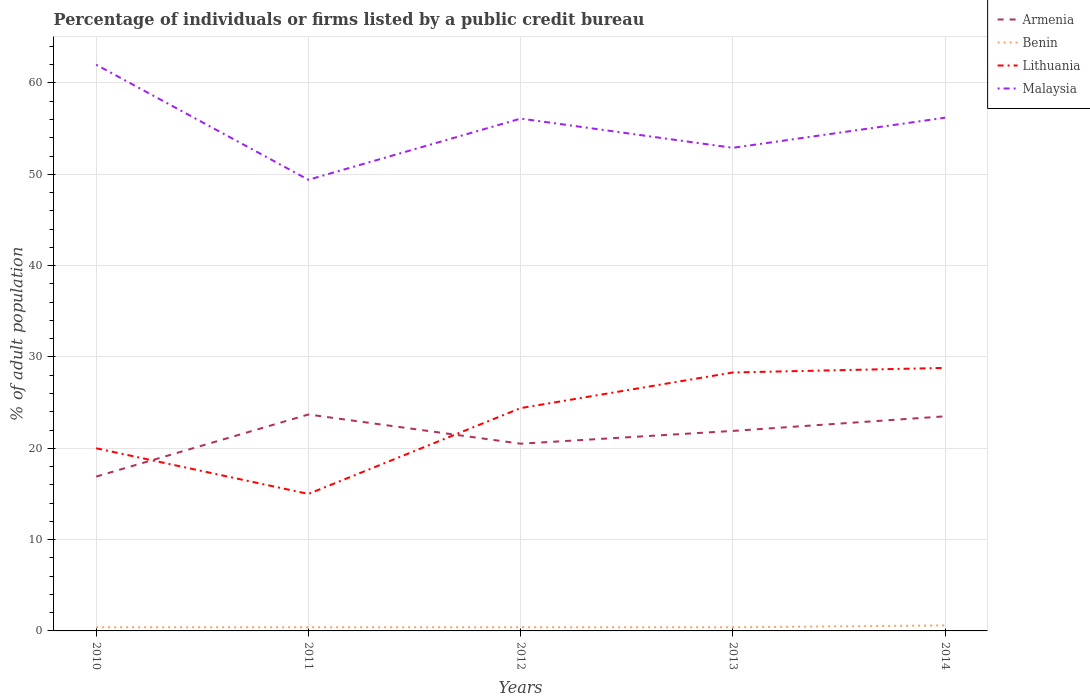How many different coloured lines are there?
Offer a very short reply. 4. Is the number of lines equal to the number of legend labels?
Provide a short and direct response. Yes. What is the total percentage of population listed by a public credit bureau in Malaysia in the graph?
Offer a terse response. 5.8. What is the difference between the highest and the second highest percentage of population listed by a public credit bureau in Malaysia?
Offer a very short reply. 12.6. What is the difference between the highest and the lowest percentage of population listed by a public credit bureau in Lithuania?
Your answer should be compact. 3. How many years are there in the graph?
Keep it short and to the point. 5. What is the difference between two consecutive major ticks on the Y-axis?
Offer a terse response. 10. Where does the legend appear in the graph?
Make the answer very short. Top right. What is the title of the graph?
Provide a short and direct response. Percentage of individuals or firms listed by a public credit bureau. Does "Bangladesh" appear as one of the legend labels in the graph?
Ensure brevity in your answer.  No. What is the label or title of the Y-axis?
Keep it short and to the point. % of adult population. What is the % of adult population of Armenia in 2011?
Make the answer very short. 23.7. What is the % of adult population in Benin in 2011?
Make the answer very short. 0.4. What is the % of adult population of Malaysia in 2011?
Keep it short and to the point. 49.4. What is the % of adult population of Lithuania in 2012?
Keep it short and to the point. 24.4. What is the % of adult population in Malaysia in 2012?
Make the answer very short. 56.1. What is the % of adult population of Armenia in 2013?
Keep it short and to the point. 21.9. What is the % of adult population in Benin in 2013?
Provide a short and direct response. 0.4. What is the % of adult population of Lithuania in 2013?
Offer a very short reply. 28.3. What is the % of adult population in Malaysia in 2013?
Offer a terse response. 52.9. What is the % of adult population of Lithuania in 2014?
Your answer should be compact. 28.8. What is the % of adult population in Malaysia in 2014?
Provide a short and direct response. 56.2. Across all years, what is the maximum % of adult population of Armenia?
Your answer should be compact. 23.7. Across all years, what is the maximum % of adult population of Lithuania?
Offer a terse response. 28.8. Across all years, what is the minimum % of adult population of Benin?
Keep it short and to the point. 0.4. Across all years, what is the minimum % of adult population in Lithuania?
Make the answer very short. 15. Across all years, what is the minimum % of adult population of Malaysia?
Offer a terse response. 49.4. What is the total % of adult population of Armenia in the graph?
Offer a terse response. 106.5. What is the total % of adult population of Benin in the graph?
Make the answer very short. 2.2. What is the total % of adult population in Lithuania in the graph?
Provide a short and direct response. 116.5. What is the total % of adult population in Malaysia in the graph?
Keep it short and to the point. 276.6. What is the difference between the % of adult population of Benin in 2010 and that in 2011?
Ensure brevity in your answer.  0. What is the difference between the % of adult population of Armenia in 2010 and that in 2012?
Your response must be concise. -3.6. What is the difference between the % of adult population in Malaysia in 2010 and that in 2012?
Provide a short and direct response. 5.9. What is the difference between the % of adult population of Lithuania in 2010 and that in 2013?
Ensure brevity in your answer.  -8.3. What is the difference between the % of adult population of Armenia in 2010 and that in 2014?
Keep it short and to the point. -6.6. What is the difference between the % of adult population of Benin in 2010 and that in 2014?
Provide a succinct answer. -0.2. What is the difference between the % of adult population of Armenia in 2011 and that in 2012?
Provide a succinct answer. 3.2. What is the difference between the % of adult population in Benin in 2011 and that in 2012?
Keep it short and to the point. 0. What is the difference between the % of adult population of Lithuania in 2011 and that in 2012?
Keep it short and to the point. -9.4. What is the difference between the % of adult population in Benin in 2011 and that in 2013?
Make the answer very short. 0. What is the difference between the % of adult population in Malaysia in 2011 and that in 2013?
Ensure brevity in your answer.  -3.5. What is the difference between the % of adult population of Lithuania in 2011 and that in 2014?
Offer a terse response. -13.8. What is the difference between the % of adult population of Armenia in 2012 and that in 2013?
Keep it short and to the point. -1.4. What is the difference between the % of adult population of Benin in 2012 and that in 2013?
Keep it short and to the point. 0. What is the difference between the % of adult population of Lithuania in 2012 and that in 2013?
Your answer should be compact. -3.9. What is the difference between the % of adult population in Malaysia in 2012 and that in 2013?
Your answer should be compact. 3.2. What is the difference between the % of adult population of Benin in 2012 and that in 2014?
Your answer should be compact. -0.2. What is the difference between the % of adult population in Lithuania in 2012 and that in 2014?
Offer a very short reply. -4.4. What is the difference between the % of adult population of Malaysia in 2012 and that in 2014?
Give a very brief answer. -0.1. What is the difference between the % of adult population in Benin in 2013 and that in 2014?
Offer a very short reply. -0.2. What is the difference between the % of adult population in Lithuania in 2013 and that in 2014?
Provide a short and direct response. -0.5. What is the difference between the % of adult population of Malaysia in 2013 and that in 2014?
Make the answer very short. -3.3. What is the difference between the % of adult population in Armenia in 2010 and the % of adult population in Lithuania in 2011?
Keep it short and to the point. 1.9. What is the difference between the % of adult population of Armenia in 2010 and the % of adult population of Malaysia in 2011?
Ensure brevity in your answer.  -32.5. What is the difference between the % of adult population of Benin in 2010 and the % of adult population of Lithuania in 2011?
Keep it short and to the point. -14.6. What is the difference between the % of adult population of Benin in 2010 and the % of adult population of Malaysia in 2011?
Give a very brief answer. -49. What is the difference between the % of adult population in Lithuania in 2010 and the % of adult population in Malaysia in 2011?
Provide a short and direct response. -29.4. What is the difference between the % of adult population in Armenia in 2010 and the % of adult population in Benin in 2012?
Offer a terse response. 16.5. What is the difference between the % of adult population in Armenia in 2010 and the % of adult population in Malaysia in 2012?
Your answer should be very brief. -39.2. What is the difference between the % of adult population in Benin in 2010 and the % of adult population in Malaysia in 2012?
Provide a succinct answer. -55.7. What is the difference between the % of adult population in Lithuania in 2010 and the % of adult population in Malaysia in 2012?
Provide a short and direct response. -36.1. What is the difference between the % of adult population of Armenia in 2010 and the % of adult population of Lithuania in 2013?
Give a very brief answer. -11.4. What is the difference between the % of adult population in Armenia in 2010 and the % of adult population in Malaysia in 2013?
Keep it short and to the point. -36. What is the difference between the % of adult population in Benin in 2010 and the % of adult population in Lithuania in 2013?
Keep it short and to the point. -27.9. What is the difference between the % of adult population in Benin in 2010 and the % of adult population in Malaysia in 2013?
Your answer should be very brief. -52.5. What is the difference between the % of adult population in Lithuania in 2010 and the % of adult population in Malaysia in 2013?
Give a very brief answer. -32.9. What is the difference between the % of adult population of Armenia in 2010 and the % of adult population of Malaysia in 2014?
Make the answer very short. -39.3. What is the difference between the % of adult population of Benin in 2010 and the % of adult population of Lithuania in 2014?
Keep it short and to the point. -28.4. What is the difference between the % of adult population of Benin in 2010 and the % of adult population of Malaysia in 2014?
Make the answer very short. -55.8. What is the difference between the % of adult population in Lithuania in 2010 and the % of adult population in Malaysia in 2014?
Offer a terse response. -36.2. What is the difference between the % of adult population of Armenia in 2011 and the % of adult population of Benin in 2012?
Provide a succinct answer. 23.3. What is the difference between the % of adult population of Armenia in 2011 and the % of adult population of Malaysia in 2012?
Provide a succinct answer. -32.4. What is the difference between the % of adult population in Benin in 2011 and the % of adult population in Malaysia in 2012?
Keep it short and to the point. -55.7. What is the difference between the % of adult population in Lithuania in 2011 and the % of adult population in Malaysia in 2012?
Your response must be concise. -41.1. What is the difference between the % of adult population of Armenia in 2011 and the % of adult population of Benin in 2013?
Offer a very short reply. 23.3. What is the difference between the % of adult population in Armenia in 2011 and the % of adult population in Lithuania in 2013?
Ensure brevity in your answer.  -4.6. What is the difference between the % of adult population of Armenia in 2011 and the % of adult population of Malaysia in 2013?
Ensure brevity in your answer.  -29.2. What is the difference between the % of adult population in Benin in 2011 and the % of adult population in Lithuania in 2013?
Your answer should be compact. -27.9. What is the difference between the % of adult population in Benin in 2011 and the % of adult population in Malaysia in 2013?
Provide a succinct answer. -52.5. What is the difference between the % of adult population in Lithuania in 2011 and the % of adult population in Malaysia in 2013?
Provide a short and direct response. -37.9. What is the difference between the % of adult population in Armenia in 2011 and the % of adult population in Benin in 2014?
Your answer should be very brief. 23.1. What is the difference between the % of adult population of Armenia in 2011 and the % of adult population of Malaysia in 2014?
Your answer should be compact. -32.5. What is the difference between the % of adult population in Benin in 2011 and the % of adult population in Lithuania in 2014?
Keep it short and to the point. -28.4. What is the difference between the % of adult population of Benin in 2011 and the % of adult population of Malaysia in 2014?
Ensure brevity in your answer.  -55.8. What is the difference between the % of adult population of Lithuania in 2011 and the % of adult population of Malaysia in 2014?
Make the answer very short. -41.2. What is the difference between the % of adult population in Armenia in 2012 and the % of adult population in Benin in 2013?
Give a very brief answer. 20.1. What is the difference between the % of adult population of Armenia in 2012 and the % of adult population of Malaysia in 2013?
Your answer should be compact. -32.4. What is the difference between the % of adult population of Benin in 2012 and the % of adult population of Lithuania in 2013?
Keep it short and to the point. -27.9. What is the difference between the % of adult population in Benin in 2012 and the % of adult population in Malaysia in 2013?
Make the answer very short. -52.5. What is the difference between the % of adult population in Lithuania in 2012 and the % of adult population in Malaysia in 2013?
Give a very brief answer. -28.5. What is the difference between the % of adult population in Armenia in 2012 and the % of adult population in Lithuania in 2014?
Your response must be concise. -8.3. What is the difference between the % of adult population of Armenia in 2012 and the % of adult population of Malaysia in 2014?
Offer a very short reply. -35.7. What is the difference between the % of adult population of Benin in 2012 and the % of adult population of Lithuania in 2014?
Offer a terse response. -28.4. What is the difference between the % of adult population of Benin in 2012 and the % of adult population of Malaysia in 2014?
Ensure brevity in your answer.  -55.8. What is the difference between the % of adult population in Lithuania in 2012 and the % of adult population in Malaysia in 2014?
Provide a short and direct response. -31.8. What is the difference between the % of adult population in Armenia in 2013 and the % of adult population in Benin in 2014?
Your response must be concise. 21.3. What is the difference between the % of adult population of Armenia in 2013 and the % of adult population of Lithuania in 2014?
Make the answer very short. -6.9. What is the difference between the % of adult population in Armenia in 2013 and the % of adult population in Malaysia in 2014?
Ensure brevity in your answer.  -34.3. What is the difference between the % of adult population of Benin in 2013 and the % of adult population of Lithuania in 2014?
Offer a terse response. -28.4. What is the difference between the % of adult population of Benin in 2013 and the % of adult population of Malaysia in 2014?
Provide a short and direct response. -55.8. What is the difference between the % of adult population in Lithuania in 2013 and the % of adult population in Malaysia in 2014?
Make the answer very short. -27.9. What is the average % of adult population in Armenia per year?
Offer a terse response. 21.3. What is the average % of adult population in Benin per year?
Offer a terse response. 0.44. What is the average % of adult population of Lithuania per year?
Offer a very short reply. 23.3. What is the average % of adult population of Malaysia per year?
Your answer should be very brief. 55.32. In the year 2010, what is the difference between the % of adult population of Armenia and % of adult population of Malaysia?
Give a very brief answer. -45.1. In the year 2010, what is the difference between the % of adult population of Benin and % of adult population of Lithuania?
Keep it short and to the point. -19.6. In the year 2010, what is the difference between the % of adult population in Benin and % of adult population in Malaysia?
Make the answer very short. -61.6. In the year 2010, what is the difference between the % of adult population of Lithuania and % of adult population of Malaysia?
Provide a short and direct response. -42. In the year 2011, what is the difference between the % of adult population in Armenia and % of adult population in Benin?
Provide a short and direct response. 23.3. In the year 2011, what is the difference between the % of adult population in Armenia and % of adult population in Malaysia?
Offer a very short reply. -25.7. In the year 2011, what is the difference between the % of adult population of Benin and % of adult population of Lithuania?
Provide a succinct answer. -14.6. In the year 2011, what is the difference between the % of adult population of Benin and % of adult population of Malaysia?
Make the answer very short. -49. In the year 2011, what is the difference between the % of adult population in Lithuania and % of adult population in Malaysia?
Ensure brevity in your answer.  -34.4. In the year 2012, what is the difference between the % of adult population in Armenia and % of adult population in Benin?
Ensure brevity in your answer.  20.1. In the year 2012, what is the difference between the % of adult population of Armenia and % of adult population of Malaysia?
Your response must be concise. -35.6. In the year 2012, what is the difference between the % of adult population of Benin and % of adult population of Lithuania?
Give a very brief answer. -24. In the year 2012, what is the difference between the % of adult population of Benin and % of adult population of Malaysia?
Make the answer very short. -55.7. In the year 2012, what is the difference between the % of adult population of Lithuania and % of adult population of Malaysia?
Offer a very short reply. -31.7. In the year 2013, what is the difference between the % of adult population in Armenia and % of adult population in Lithuania?
Give a very brief answer. -6.4. In the year 2013, what is the difference between the % of adult population of Armenia and % of adult population of Malaysia?
Your answer should be very brief. -31. In the year 2013, what is the difference between the % of adult population of Benin and % of adult population of Lithuania?
Your answer should be very brief. -27.9. In the year 2013, what is the difference between the % of adult population of Benin and % of adult population of Malaysia?
Offer a very short reply. -52.5. In the year 2013, what is the difference between the % of adult population of Lithuania and % of adult population of Malaysia?
Give a very brief answer. -24.6. In the year 2014, what is the difference between the % of adult population of Armenia and % of adult population of Benin?
Offer a terse response. 22.9. In the year 2014, what is the difference between the % of adult population in Armenia and % of adult population in Lithuania?
Provide a succinct answer. -5.3. In the year 2014, what is the difference between the % of adult population of Armenia and % of adult population of Malaysia?
Give a very brief answer. -32.7. In the year 2014, what is the difference between the % of adult population of Benin and % of adult population of Lithuania?
Give a very brief answer. -28.2. In the year 2014, what is the difference between the % of adult population of Benin and % of adult population of Malaysia?
Your answer should be very brief. -55.6. In the year 2014, what is the difference between the % of adult population in Lithuania and % of adult population in Malaysia?
Provide a short and direct response. -27.4. What is the ratio of the % of adult population in Armenia in 2010 to that in 2011?
Offer a very short reply. 0.71. What is the ratio of the % of adult population of Benin in 2010 to that in 2011?
Give a very brief answer. 1. What is the ratio of the % of adult population in Malaysia in 2010 to that in 2011?
Give a very brief answer. 1.26. What is the ratio of the % of adult population of Armenia in 2010 to that in 2012?
Your answer should be compact. 0.82. What is the ratio of the % of adult population in Benin in 2010 to that in 2012?
Keep it short and to the point. 1. What is the ratio of the % of adult population of Lithuania in 2010 to that in 2012?
Provide a short and direct response. 0.82. What is the ratio of the % of adult population in Malaysia in 2010 to that in 2012?
Provide a short and direct response. 1.11. What is the ratio of the % of adult population in Armenia in 2010 to that in 2013?
Make the answer very short. 0.77. What is the ratio of the % of adult population of Benin in 2010 to that in 2013?
Your response must be concise. 1. What is the ratio of the % of adult population of Lithuania in 2010 to that in 2013?
Provide a succinct answer. 0.71. What is the ratio of the % of adult population in Malaysia in 2010 to that in 2013?
Your answer should be very brief. 1.17. What is the ratio of the % of adult population of Armenia in 2010 to that in 2014?
Your response must be concise. 0.72. What is the ratio of the % of adult population of Lithuania in 2010 to that in 2014?
Your answer should be very brief. 0.69. What is the ratio of the % of adult population of Malaysia in 2010 to that in 2014?
Your response must be concise. 1.1. What is the ratio of the % of adult population of Armenia in 2011 to that in 2012?
Offer a very short reply. 1.16. What is the ratio of the % of adult population in Benin in 2011 to that in 2012?
Offer a very short reply. 1. What is the ratio of the % of adult population of Lithuania in 2011 to that in 2012?
Make the answer very short. 0.61. What is the ratio of the % of adult population of Malaysia in 2011 to that in 2012?
Make the answer very short. 0.88. What is the ratio of the % of adult population in Armenia in 2011 to that in 2013?
Keep it short and to the point. 1.08. What is the ratio of the % of adult population of Benin in 2011 to that in 2013?
Give a very brief answer. 1. What is the ratio of the % of adult population in Lithuania in 2011 to that in 2013?
Provide a short and direct response. 0.53. What is the ratio of the % of adult population of Malaysia in 2011 to that in 2013?
Keep it short and to the point. 0.93. What is the ratio of the % of adult population of Armenia in 2011 to that in 2014?
Your response must be concise. 1.01. What is the ratio of the % of adult population in Lithuania in 2011 to that in 2014?
Your answer should be very brief. 0.52. What is the ratio of the % of adult population in Malaysia in 2011 to that in 2014?
Your answer should be compact. 0.88. What is the ratio of the % of adult population of Armenia in 2012 to that in 2013?
Your response must be concise. 0.94. What is the ratio of the % of adult population of Benin in 2012 to that in 2013?
Your answer should be very brief. 1. What is the ratio of the % of adult population of Lithuania in 2012 to that in 2013?
Keep it short and to the point. 0.86. What is the ratio of the % of adult population of Malaysia in 2012 to that in 2013?
Give a very brief answer. 1.06. What is the ratio of the % of adult population in Armenia in 2012 to that in 2014?
Your response must be concise. 0.87. What is the ratio of the % of adult population in Lithuania in 2012 to that in 2014?
Provide a succinct answer. 0.85. What is the ratio of the % of adult population of Armenia in 2013 to that in 2014?
Give a very brief answer. 0.93. What is the ratio of the % of adult population of Benin in 2013 to that in 2014?
Your answer should be compact. 0.67. What is the ratio of the % of adult population of Lithuania in 2013 to that in 2014?
Keep it short and to the point. 0.98. What is the ratio of the % of adult population in Malaysia in 2013 to that in 2014?
Offer a very short reply. 0.94. What is the difference between the highest and the second highest % of adult population of Armenia?
Offer a very short reply. 0.2. What is the difference between the highest and the second highest % of adult population of Benin?
Provide a short and direct response. 0.2. What is the difference between the highest and the lowest % of adult population in Benin?
Offer a terse response. 0.2. What is the difference between the highest and the lowest % of adult population in Lithuania?
Your answer should be compact. 13.8. 